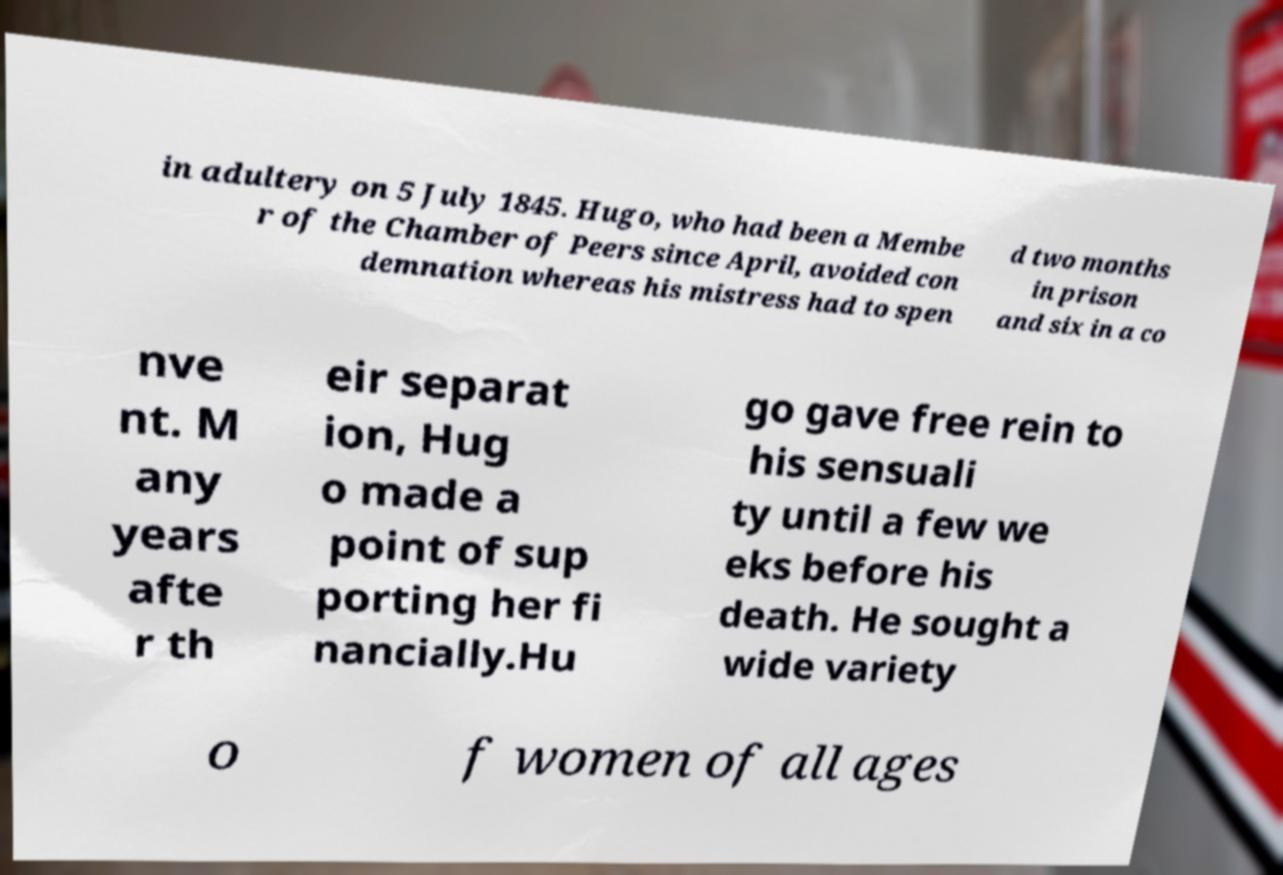Can you read and provide the text displayed in the image?This photo seems to have some interesting text. Can you extract and type it out for me? in adultery on 5 July 1845. Hugo, who had been a Membe r of the Chamber of Peers since April, avoided con demnation whereas his mistress had to spen d two months in prison and six in a co nve nt. M any years afte r th eir separat ion, Hug o made a point of sup porting her fi nancially.Hu go gave free rein to his sensuali ty until a few we eks before his death. He sought a wide variety o f women of all ages 